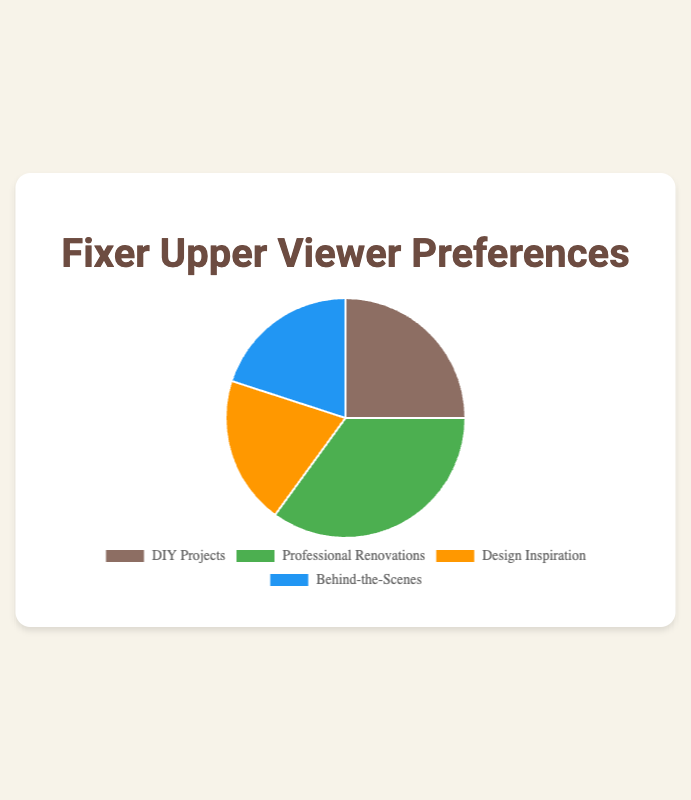What category has the highest percentage? By looking at the pie chart, we can see that the largest segment corresponds to Professional Renovations.
Answer: Professional Renovations Which two categories have an equal percentage? The pie chart shows that Design Inspiration and Behind-the-Scenes both have the same size segments, indicating they share the same percentage.
Answer: Design Inspiration and Behind-the-Scenes What percentage of viewers prefer Professional Renovations? By checking the segment labeled Professional Renovations, it is clear that it occupies 35% of the pie chart.
Answer: 35% How much more popular is Professional Renovations compared to DIY Projects? Professional Renovations has 35% and DIY Projects has 25%. To find the difference: 35% - 25% = 10%.
Answer: 10% What is the combined percentage of viewers who prefer Design Inspiration and Behind-the-Scenes? Both categories have a percentage of 20% each. Adding them together: 20% + 20% = 40%.
Answer: 40% Which categories together form half of the viewer preferences? The combined percentage of Design Inspiration (20%) and Behind-the-Scenes (20%) is 40%. Adding DIY Projects (25%) results in more than 50%. However, combining DIY Projects (25%) and Professional Renovations (35%) yields exactly 60%, which exceeds 50%. Therefore, combining DIY Projects (25%) and either Design Inspiration or Behind-the-Scenes (20%) results in less than 50%. Hence, no two categories sum up to exactly 50%.
Answer: None Which segment is represented by the color green in the pie chart? The green segment represents Professional Renovations, as indicated in the pie chart.
Answer: Professional Renovations If the percentage of viewers who prefer Design Inspiration increased by 5%, what would the new percentage be? Currently, Design Inspiration is at 20%. Adding 5% to it gives: 20% + 5% = 25%.
Answer: 25% What is the second most preferred category? By comparing the sizes of the segments, the next largest after Professional Renovations (35%) is DIY Projects, which occupies 25% of the chart.
Answer: DIY Projects What fraction of viewers prefer Behind-the-Scenes? The pie chart shows Behind-the-Scenes accounts for 20%, which can be expressed as 20/100 or simplified to 1/5.
Answer: 1/5 